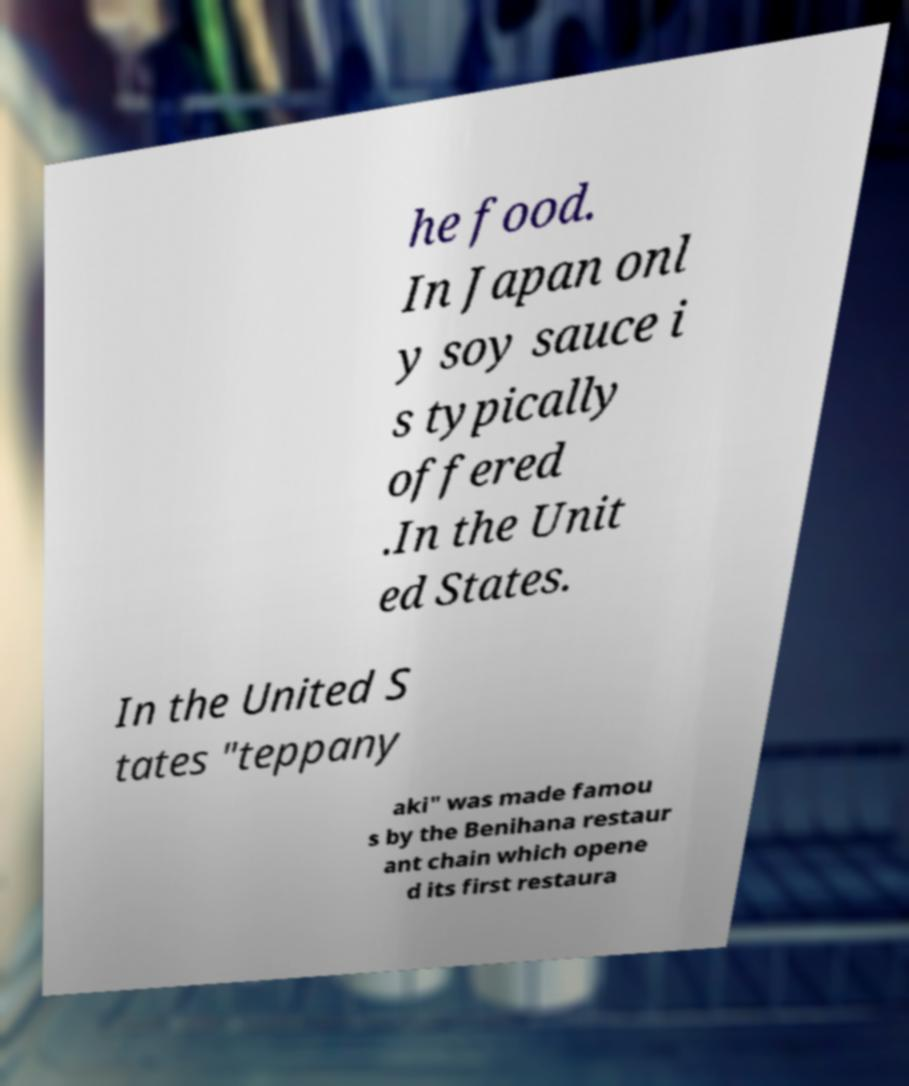I need the written content from this picture converted into text. Can you do that? he food. In Japan onl y soy sauce i s typically offered .In the Unit ed States. In the United S tates "teppany aki" was made famou s by the Benihana restaur ant chain which opene d its first restaura 